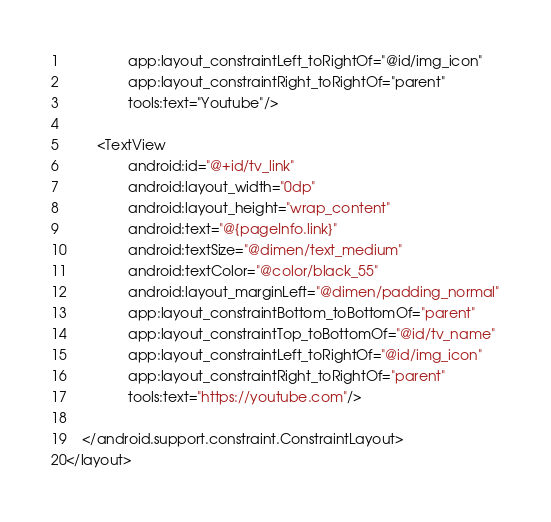Convert code to text. <code><loc_0><loc_0><loc_500><loc_500><_XML_>                app:layout_constraintLeft_toRightOf="@id/img_icon"
                app:layout_constraintRight_toRightOf="parent"
                tools:text="Youtube"/>

        <TextView
                android:id="@+id/tv_link"
                android:layout_width="0dp"
                android:layout_height="wrap_content"
                android:text="@{pageInfo.link}"
                android:textSize="@dimen/text_medium"
                android:textColor="@color/black_55"
                android:layout_marginLeft="@dimen/padding_normal"
                app:layout_constraintBottom_toBottomOf="parent"
                app:layout_constraintTop_toBottomOf="@id/tv_name"
                app:layout_constraintLeft_toRightOf="@id/img_icon"
                app:layout_constraintRight_toRightOf="parent"
                tools:text="https://youtube.com"/>

    </android.support.constraint.ConstraintLayout>
</layout>
</code> 